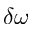<formula> <loc_0><loc_0><loc_500><loc_500>\delta \omega</formula> 